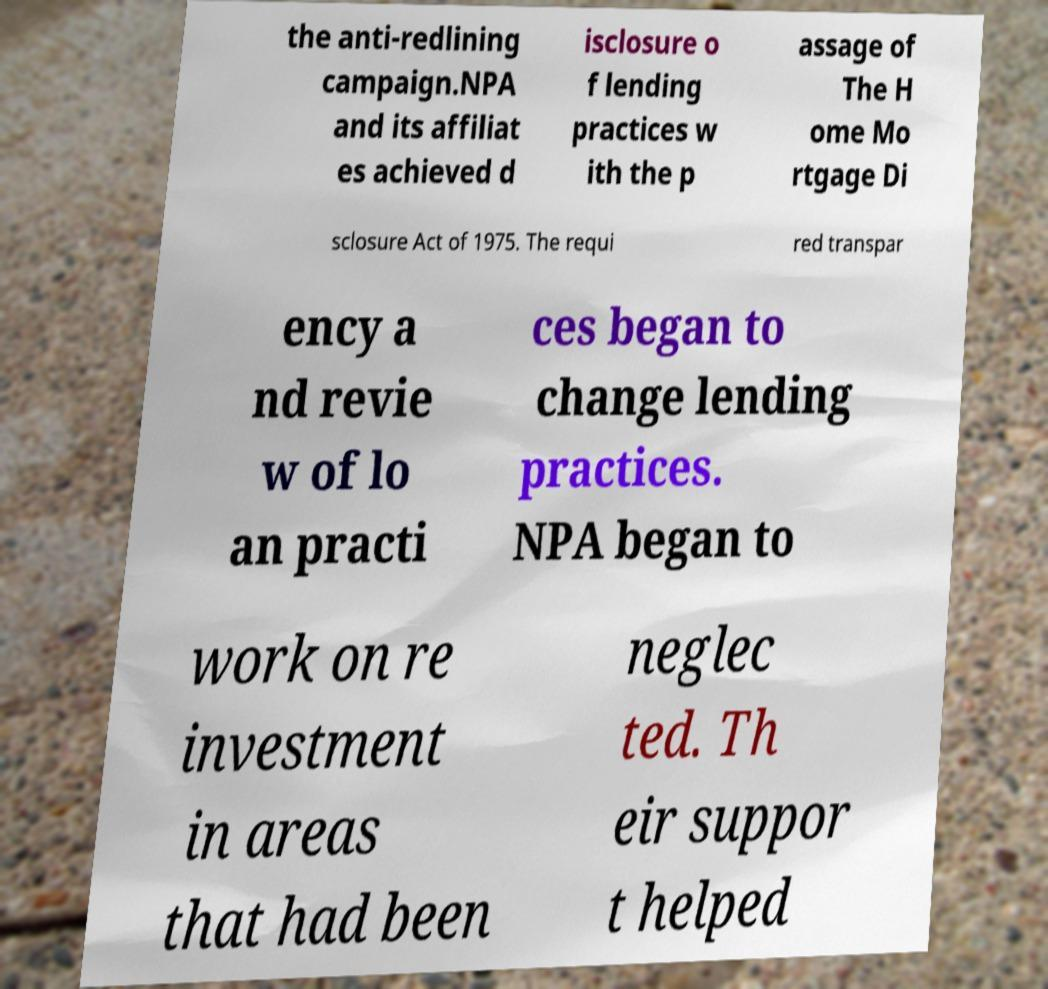Could you assist in decoding the text presented in this image and type it out clearly? the anti-redlining campaign.NPA and its affiliat es achieved d isclosure o f lending practices w ith the p assage of The H ome Mo rtgage Di sclosure Act of 1975. The requi red transpar ency a nd revie w of lo an practi ces began to change lending practices. NPA began to work on re investment in areas that had been neglec ted. Th eir suppor t helped 